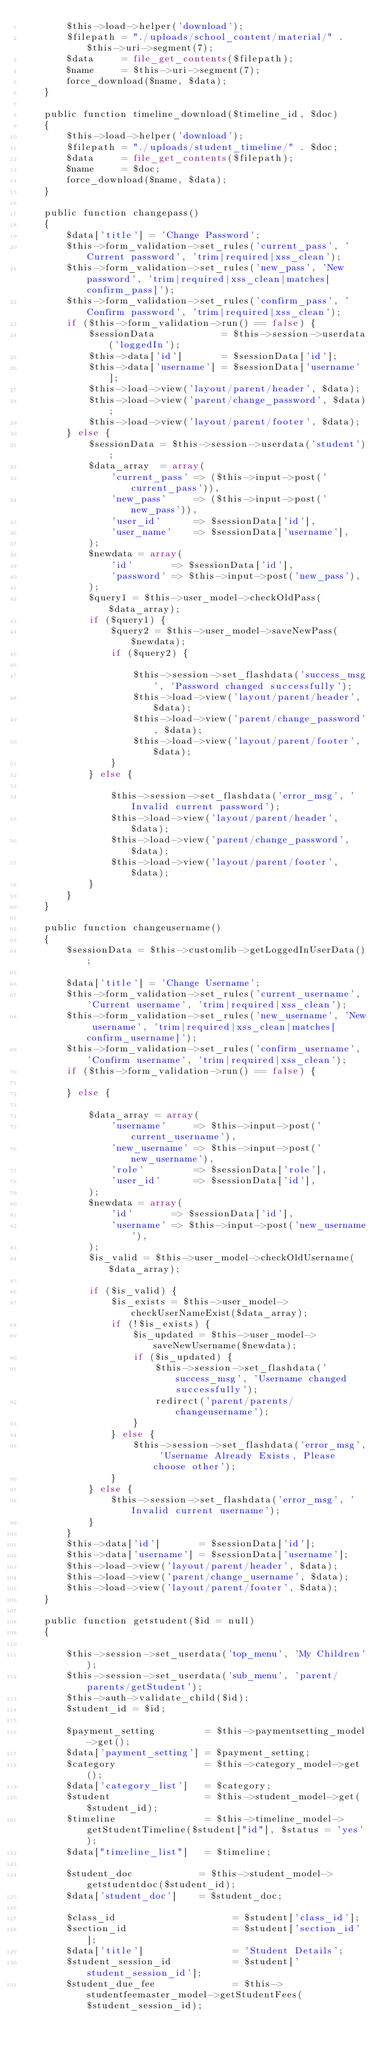Convert code to text. <code><loc_0><loc_0><loc_500><loc_500><_PHP_>        $this->load->helper('download');
        $filepath = "./uploads/school_content/material/" . $this->uri->segment(7);
        $data     = file_get_contents($filepath);
        $name     = $this->uri->segment(7);
        force_download($name, $data);
    }

    public function timeline_download($timeline_id, $doc)
    {
        $this->load->helper('download');
        $filepath = "./uploads/student_timeline/" . $doc;
        $data     = file_get_contents($filepath);
        $name     = $doc;
        force_download($name, $data);
    }

    public function changepass()
    {
        $data['title'] = 'Change Password';
        $this->form_validation->set_rules('current_pass', 'Current password', 'trim|required|xss_clean');
        $this->form_validation->set_rules('new_pass', 'New password', 'trim|required|xss_clean|matches[confirm_pass]');
        $this->form_validation->set_rules('confirm_pass', 'Confirm password', 'trim|required|xss_clean');
        if ($this->form_validation->run() == false) {
            $sessionData            = $this->session->userdata('loggedIn');
            $this->data['id']       = $sessionData['id'];
            $this->data['username'] = $sessionData['username'];
            $this->load->view('layout/parent/header', $data);
            $this->load->view('parent/change_password', $data);
            $this->load->view('layout/parent/footer', $data);
        } else {
            $sessionData = $this->session->userdata('student');
            $data_array  = array(
                'current_pass' => ($this->input->post('current_pass')),
                'new_pass'     => ($this->input->post('new_pass')),
                'user_id'      => $sessionData['id'],
                'user_name'    => $sessionData['username'],
            );
            $newdata = array(
                'id'       => $sessionData['id'],
                'password' => $this->input->post('new_pass'),
            );
            $query1 = $this->user_model->checkOldPass($data_array);
            if ($query1) {
                $query2 = $this->user_model->saveNewPass($newdata);
                if ($query2) {

                    $this->session->set_flashdata('success_msg', 'Password changed successfully');
                    $this->load->view('layout/parent/header', $data);
                    $this->load->view('parent/change_password', $data);
                    $this->load->view('layout/parent/footer', $data);
                }
            } else {

                $this->session->set_flashdata('error_msg', 'Invalid current password');
                $this->load->view('layout/parent/header', $data);
                $this->load->view('parent/change_password', $data);
                $this->load->view('layout/parent/footer', $data);
            }
        }
    }

    public function changeusername()
    {
        $sessionData = $this->customlib->getLoggedInUserData();

        $data['title'] = 'Change Username';
        $this->form_validation->set_rules('current_username', 'Current username', 'trim|required|xss_clean');
        $this->form_validation->set_rules('new_username', 'New username', 'trim|required|xss_clean|matches[confirm_username]');
        $this->form_validation->set_rules('confirm_username', 'Confirm username', 'trim|required|xss_clean');
        if ($this->form_validation->run() == false) {

        } else {

            $data_array = array(
                'username'     => $this->input->post('current_username'),
                'new_username' => $this->input->post('new_username'),
                'role'         => $sessionData['role'],
                'user_id'      => $sessionData['id'],
            );
            $newdata = array(
                'id'       => $sessionData['id'],
                'username' => $this->input->post('new_username'),
            );
            $is_valid = $this->user_model->checkOldUsername($data_array);

            if ($is_valid) {
                $is_exists = $this->user_model->checkUserNameExist($data_array);
                if (!$is_exists) {
                    $is_updated = $this->user_model->saveNewUsername($newdata);
                    if ($is_updated) {
                        $this->session->set_flashdata('success_msg', 'Username changed successfully');
                        redirect('parent/parents/changeusername');
                    }
                } else {
                    $this->session->set_flashdata('error_msg', 'Username Already Exists, Please choose other');
                }
            } else {
                $this->session->set_flashdata('error_msg', 'Invalid current username');
            }
        }
        $this->data['id']       = $sessionData['id'];
        $this->data['username'] = $sessionData['username'];
        $this->load->view('layout/parent/header', $data);
        $this->load->view('parent/change_username', $data);
        $this->load->view('layout/parent/footer', $data);
    }

    public function getstudent($id = null)
    {

        $this->session->set_userdata('top_menu', 'My Children');
        $this->session->set_userdata('sub_menu', 'parent/parents/getStudent');
        $this->auth->validate_child($id);
        $student_id = $id;

        $payment_setting         = $this->paymentsetting_model->get();
        $data['payment_setting'] = $payment_setting;
        $category                = $this->category_model->get();
        $data['category_list']   = $category;
        $student                 = $this->student_model->get($student_id);
        $timeline                = $this->timeline_model->getStudentTimeline($student["id"], $status = 'yes');
        $data["timeline_list"]   = $timeline;

        $student_doc            = $this->student_model->getstudentdoc($student_id);
        $data['student_doc']    = $student_doc;

        $class_id                     = $student['class_id'];
        $section_id                   = $student['section_id'];
        $data['title']                = 'Student Details';
        $student_session_id           = $student['student_session_id'];
        $student_due_fee              = $this->studentfeemaster_model->getStudentFees($student_session_id);</code> 